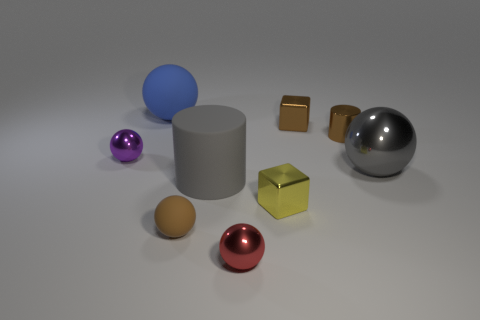Subtract all big gray shiny spheres. How many spheres are left? 4 Subtract 1 cubes. How many cubes are left? 1 Subtract all cylinders. How many objects are left? 7 Subtract all blue spheres. How many spheres are left? 4 Subtract all gray matte cubes. Subtract all small brown metallic things. How many objects are left? 7 Add 9 red metal things. How many red metal things are left? 10 Add 3 metal balls. How many metal balls exist? 6 Subtract 0 purple cylinders. How many objects are left? 9 Subtract all green cylinders. Subtract all red cubes. How many cylinders are left? 2 